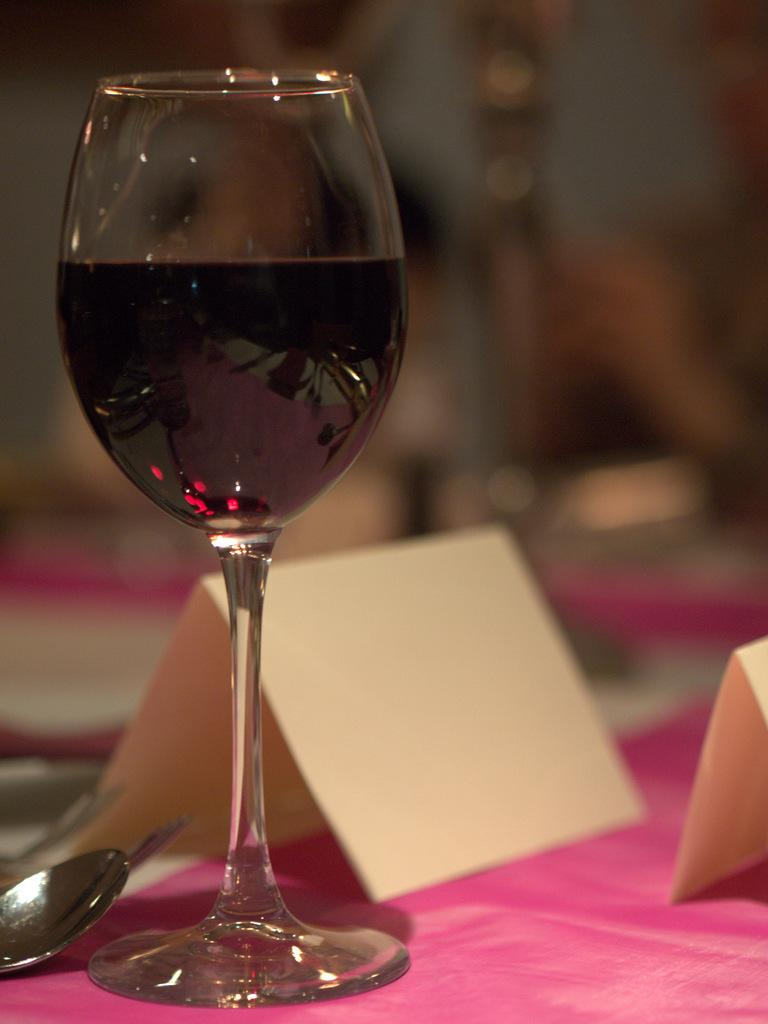What is on the table in the image? There is a glass filled with a drink, a spoon, and papers on the table. What is the color of the cloth covering the table? The table is covered with a pink cloth. Can you describe the drink in the glass? The provided facts do not specify the type of drink in the glass. What is the background of the image like? The background of the image is blurry. What story is the nose telling in the image? There is no nose present in the image, so it cannot be telling a story. 